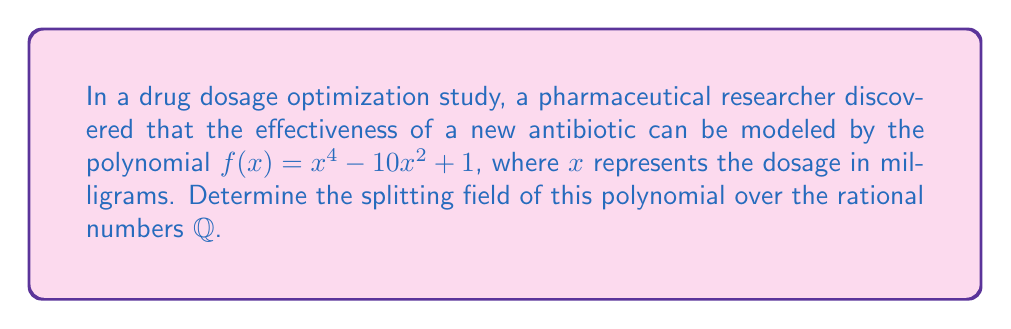Solve this math problem. To find the splitting field, we need to follow these steps:

1) First, let's factor the polynomial $f(x) = x^4 - 10x^2 + 1$:
   
   $f(x) = (x^2 - 5)^2 - 24 = (x^2 - 5 - 2\sqrt{6})(x^2 - 5 + 2\sqrt{6})$

2) Now, we can further factor each quadratic term:
   
   $(x - \sqrt{5 + 2\sqrt{6}})(x + \sqrt{5 + 2\sqrt{6}})(x - \sqrt{5 - 2\sqrt{6}})(x + \sqrt{5 - 2\sqrt{6}})$

3) The roots of $f(x)$ are:
   
   $\pm\sqrt{5 + 2\sqrt{6}}$ and $\pm\sqrt{5 - 2\sqrt{6}}$

4) The splitting field will be the smallest field containing $\mathbb{Q}$ and all these roots.

5) To construct this field, we need to adjoin $\sqrt{6}$ to $\mathbb{Q}$ first, giving us $\mathbb{Q}(\sqrt{6})$.

6) Then, we need to adjoin $\sqrt{5 + 2\sqrt{6}}$ and $\sqrt{5 - 2\sqrt{6}}$ to $\mathbb{Q}(\sqrt{6})$.

7) The resulting field is $\mathbb{Q}(\sqrt{6}, \sqrt{5 + 2\sqrt{6}}, \sqrt{5 - 2\sqrt{6}})$.

This is the smallest field containing all roots of $f(x)$, and thus the splitting field of $f(x)$ over $\mathbb{Q}$.
Answer: $\mathbb{Q}(\sqrt{6}, \sqrt{5 + 2\sqrt{6}}, \sqrt{5 - 2\sqrt{6}})$ 